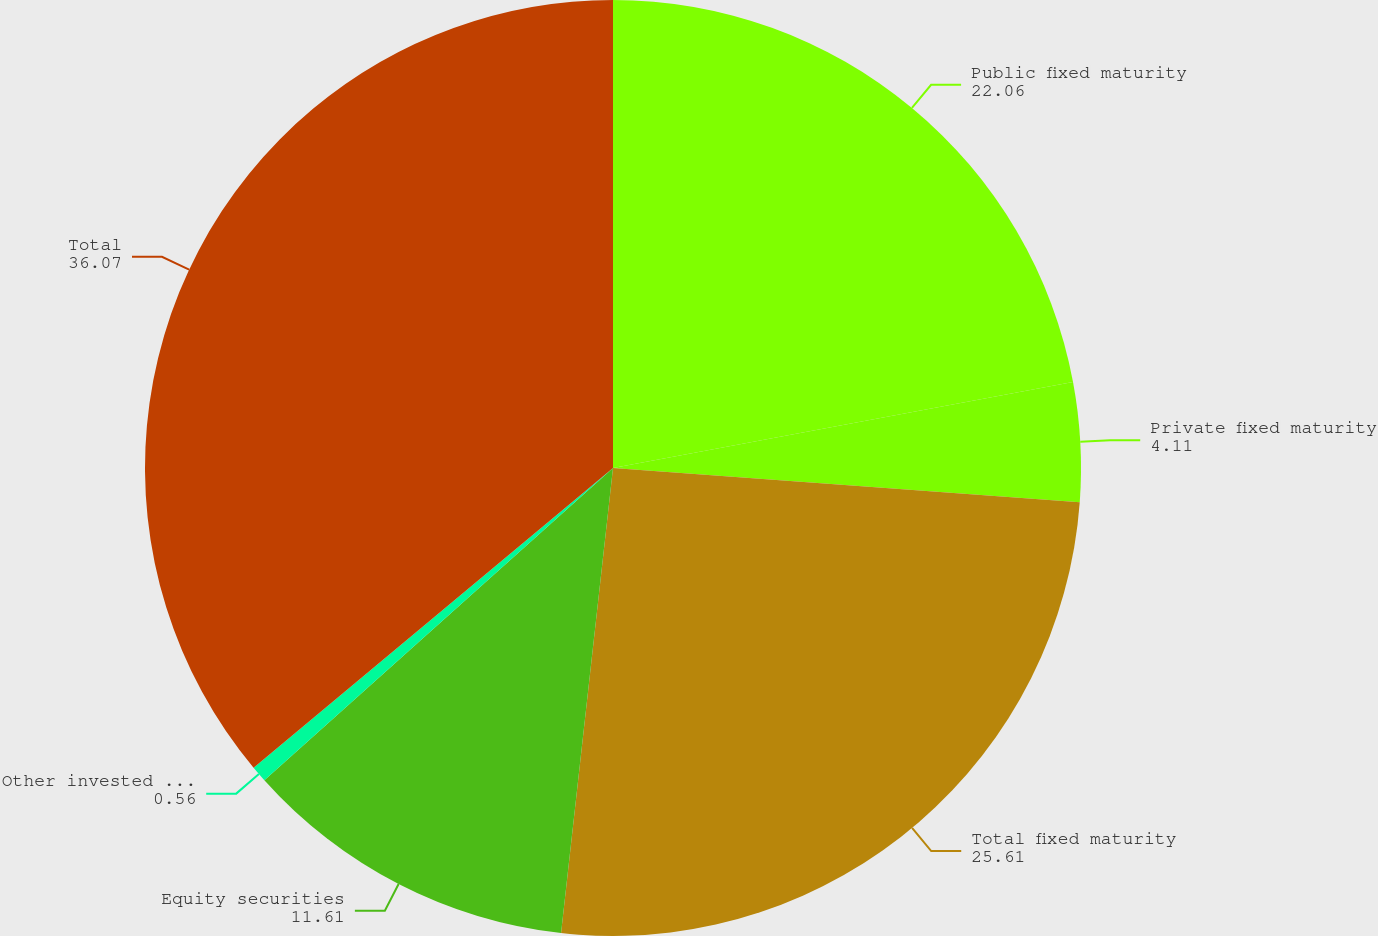Convert chart to OTSL. <chart><loc_0><loc_0><loc_500><loc_500><pie_chart><fcel>Public fixed maturity<fcel>Private fixed maturity<fcel>Total fixed maturity<fcel>Equity securities<fcel>Other invested assets(1)<fcel>Total<nl><fcel>22.06%<fcel>4.11%<fcel>25.61%<fcel>11.61%<fcel>0.56%<fcel>36.07%<nl></chart> 